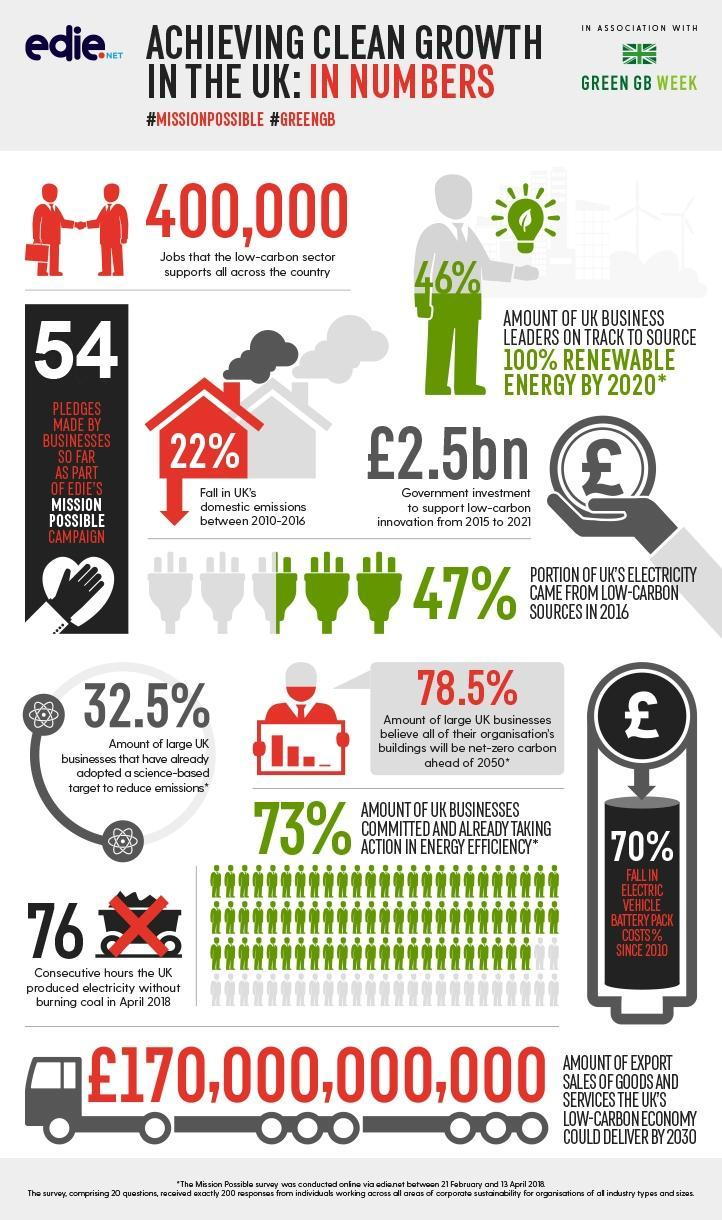What has been adopted by 32.5% of the large businesses ?
Answer the question with a short phrase. target to reduce emissions How many of the business leaders ready to source 100% renewable energy by 2020? 46% By what percent has electric vehicle battery costs decreased? 70% By what percent has domestic emissions decreased? 22% 